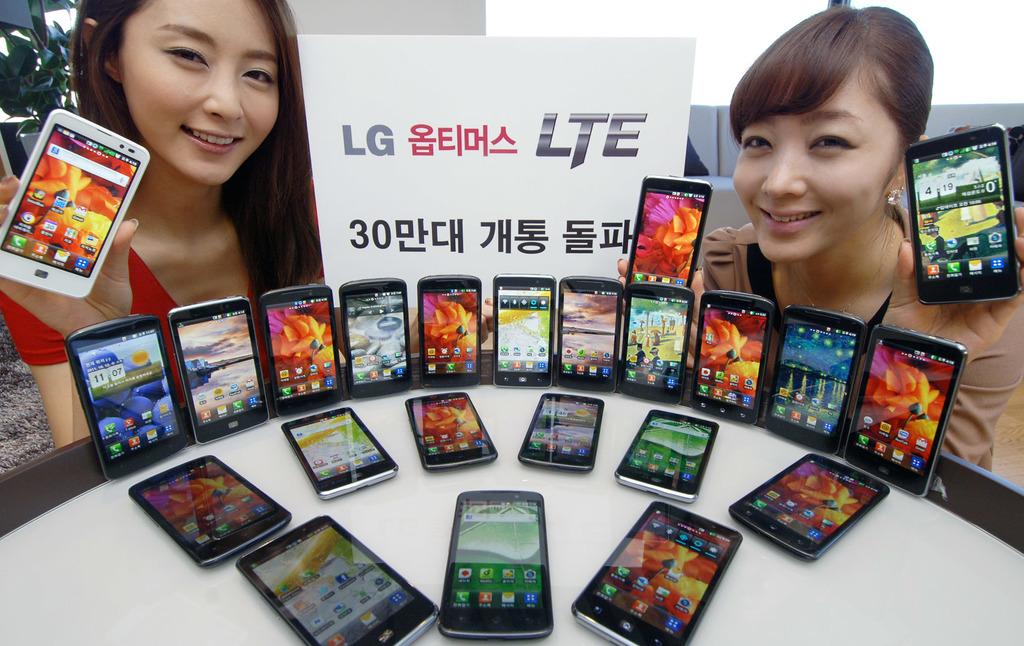What brand of phone?
Your answer should be compact. Lg. What time is it on the phone the woman on the right is holding?
Your response must be concise. Unanswerable. 